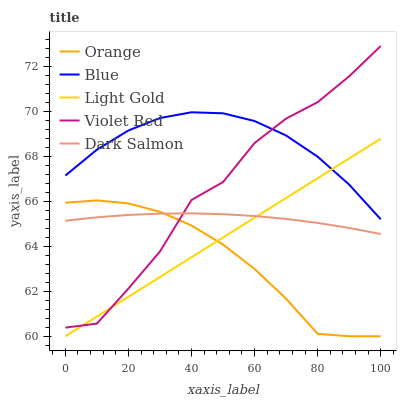Does Orange have the minimum area under the curve?
Answer yes or no. Yes. Does Violet Red have the minimum area under the curve?
Answer yes or no. No. Does Violet Red have the maximum area under the curve?
Answer yes or no. No. Is Light Gold the smoothest?
Answer yes or no. Yes. Is Violet Red the roughest?
Answer yes or no. Yes. Is Blue the smoothest?
Answer yes or no. No. Is Blue the roughest?
Answer yes or no. No. Does Violet Red have the lowest value?
Answer yes or no. No. Does Blue have the highest value?
Answer yes or no. No. Is Dark Salmon less than Blue?
Answer yes or no. Yes. Is Blue greater than Orange?
Answer yes or no. Yes. Does Dark Salmon intersect Blue?
Answer yes or no. No. 